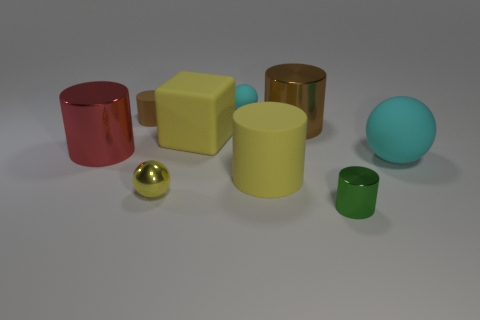Subtract all big yellow matte cylinders. How many cylinders are left? 4 Subtract all green cylinders. How many cylinders are left? 4 Subtract all purple cylinders. Subtract all red cubes. How many cylinders are left? 5 Subtract all cubes. How many objects are left? 8 Add 8 large gray shiny cylinders. How many large gray shiny cylinders exist? 8 Subtract 0 red spheres. How many objects are left? 9 Subtract all big brown cubes. Subtract all red metal objects. How many objects are left? 8 Add 5 small cyan spheres. How many small cyan spheres are left? 6 